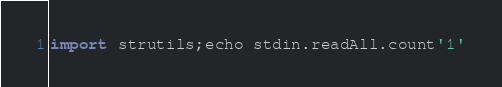<code> <loc_0><loc_0><loc_500><loc_500><_Nim_>import strutils;echo stdin.readAll.count'1'</code> 